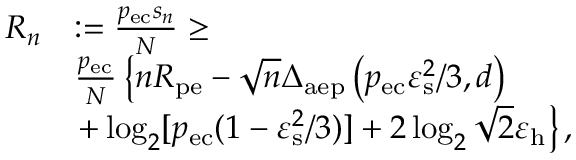Convert formula to latex. <formula><loc_0><loc_0><loc_500><loc_500>\begin{array} { r l } { R _ { n } } & { \colon = \frac { p _ { e c } s _ { n } } { N } \geq } \\ & { \frac { p _ { e c } } { N } \left \{ n R _ { p e } - \sqrt { n } \Delta _ { a e p } \left ( p _ { e c } \varepsilon _ { s } ^ { 2 } / 3 , d \right ) } \\ & { + \log _ { 2 } [ p _ { e c } ( 1 - \varepsilon _ { s } ^ { 2 } / 3 ) ] + 2 \log _ { 2 } \sqrt { 2 } \varepsilon _ { h } \right \} , } \end{array}</formula> 